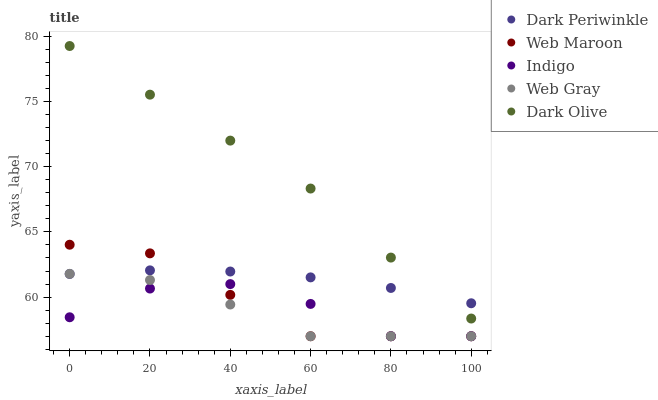Does Web Gray have the minimum area under the curve?
Answer yes or no. Yes. Does Dark Olive have the maximum area under the curve?
Answer yes or no. Yes. Does Indigo have the minimum area under the curve?
Answer yes or no. No. Does Indigo have the maximum area under the curve?
Answer yes or no. No. Is Dark Periwinkle the smoothest?
Answer yes or no. Yes. Is Indigo the roughest?
Answer yes or no. Yes. Is Web Gray the smoothest?
Answer yes or no. No. Is Web Gray the roughest?
Answer yes or no. No. Does Indigo have the lowest value?
Answer yes or no. Yes. Does Dark Periwinkle have the lowest value?
Answer yes or no. No. Does Dark Olive have the highest value?
Answer yes or no. Yes. Does Web Gray have the highest value?
Answer yes or no. No. Is Indigo less than Dark Olive?
Answer yes or no. Yes. Is Dark Olive greater than Indigo?
Answer yes or no. Yes. Does Dark Periwinkle intersect Web Gray?
Answer yes or no. Yes. Is Dark Periwinkle less than Web Gray?
Answer yes or no. No. Is Dark Periwinkle greater than Web Gray?
Answer yes or no. No. Does Indigo intersect Dark Olive?
Answer yes or no. No. 